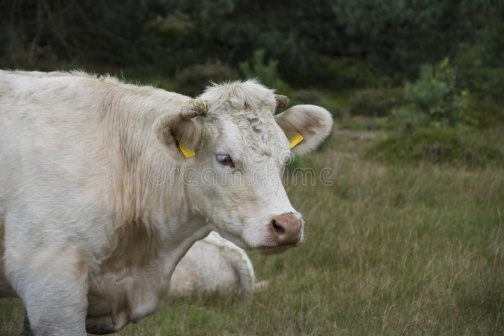What do you see happening in this image?
 The image presents a serene rural scene dominated by a single white cow. The cow, distinguished by yellow tags on its ears, stands in the middle of a grassy field. It is facing towards the right side of the image, giving the impression that it is looking at something off-frame. The cow's position in the field is such that it is surrounded by an array of greenery, including bushes and trees that form a natural backdrop. The cow's stance is calm and relaxed, indicative of a peaceful setting. There are no discernible texts or other objects in the image. The relative position of the cow and the surrounding greenery suggests that the cow is at a considerable distance from the bushes and trees in the background. The image does not contain any other objects or creatures, making the cow the central focus of the scene. The overall image gives a sense of tranquility and simplicity, characteristic of rural landscapes. 